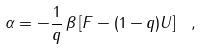Convert formula to latex. <formula><loc_0><loc_0><loc_500><loc_500>\alpha = - \frac { 1 } { q } \, \beta \left [ F - ( 1 - q ) U \right ] \ ,</formula> 